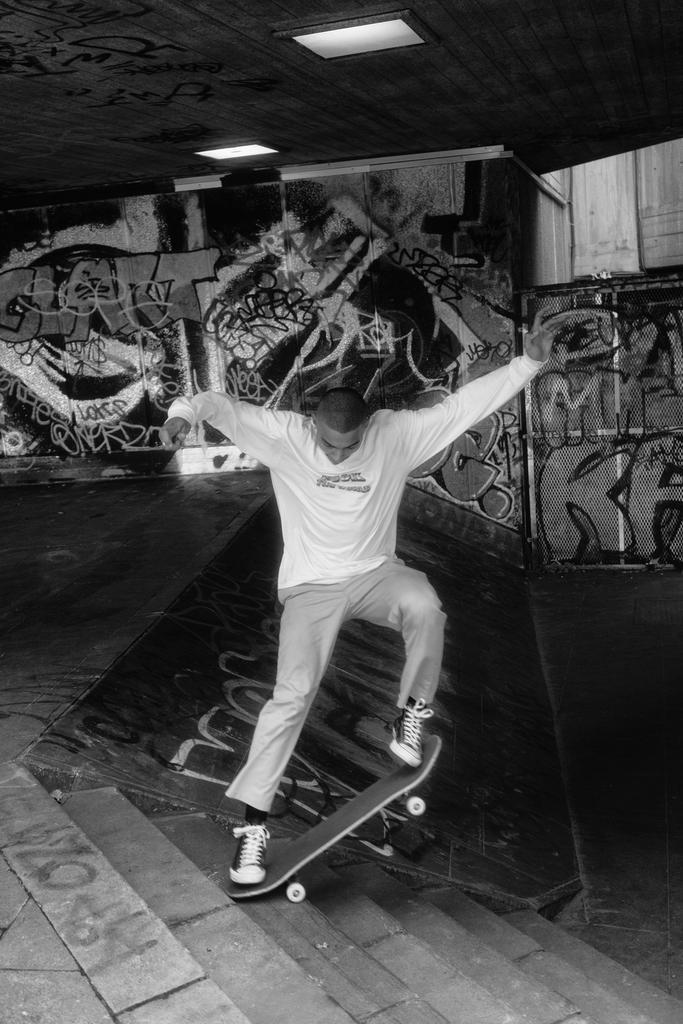In one or two sentences, can you explain what this image depicts? This image is a black and white image. This image is taken indoors. At the top of the image there is a ceiling with two lights. At the bottom of the image there are a few stairs. In the background there is a wall with a graffiti on it. In the middle of the image a man is skating with a skating board and there is a skating rink with a text on it. 